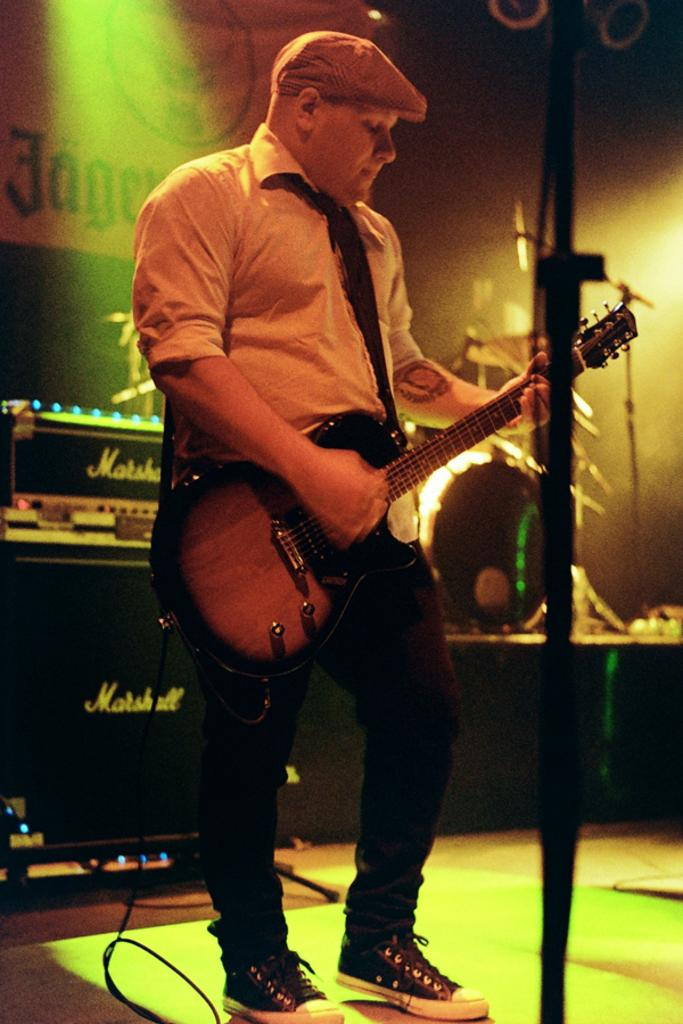Who is in the image? There is a person in the image. What is the person wearing? The person is wearing a white shirt. What is the person doing in the image? The person is playing a guitar. What can be seen in the background of the image? There is a sound box in the background of the image. Where is the nest located in the image? There is no nest present in the image. What grade is the person in the image? The provided facts do not mention the person's grade or age, so it cannot be determined from the image. 